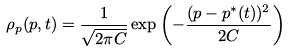<formula> <loc_0><loc_0><loc_500><loc_500>\rho _ { p } ( p , t ) = \frac { 1 } { \sqrt { 2 \pi C } } \exp { \left ( - \frac { ( p - p ^ { * } ( t ) ) ^ { 2 } } { 2 C } \right ) }</formula> 